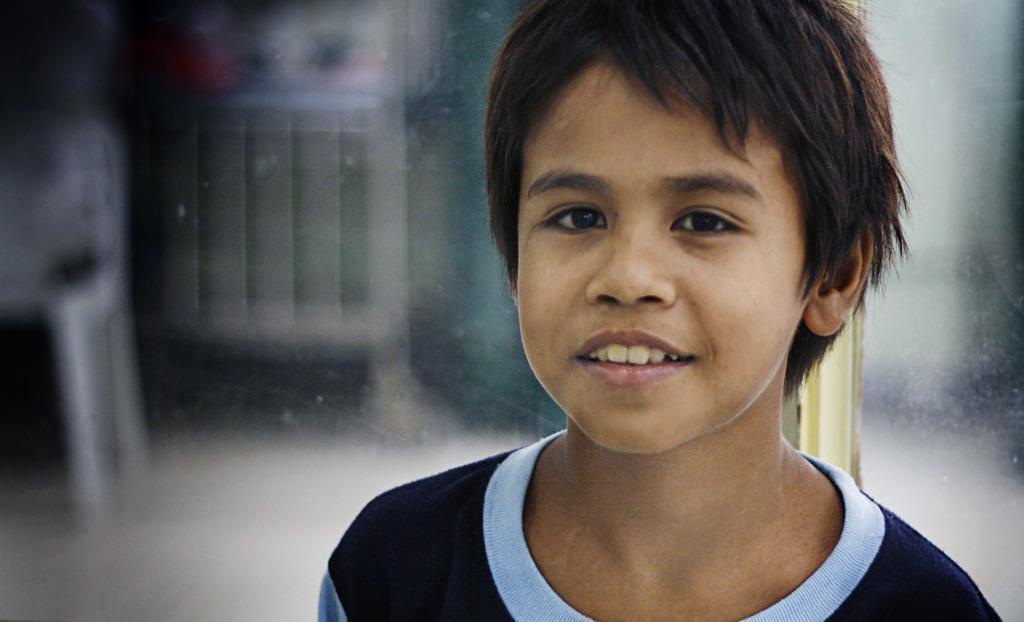Could you give a brief overview of what you see in this image? In this picture we can see a boy is smiling and wearing blue color t-shirt. 